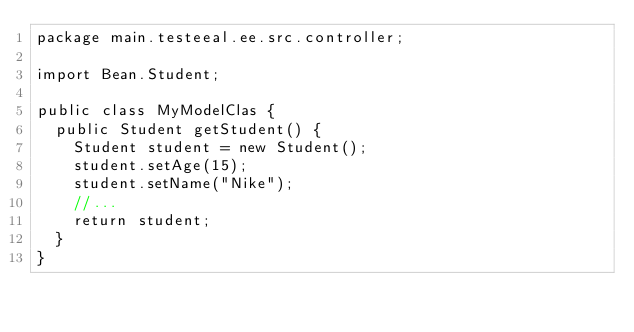Convert code to text. <code><loc_0><loc_0><loc_500><loc_500><_Java_>package main.testeeal.ee.src.controller;

import Bean.Student;

public class MyModelClas {
  public Student getStudent() {
    Student student = new Student();
    student.setAge(15);
    student.setName("Nike");
    //...
    return student;
  }
}
</code> 